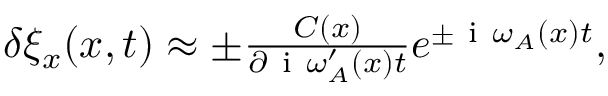Convert formula to latex. <formula><loc_0><loc_0><loc_500><loc_500>\begin{array} { r } { \delta \xi _ { x } ( x , t ) \approx \pm \frac { C ( x ) } { \partial i \omega _ { A } ^ { \prime } ( x ) t } e ^ { \pm i \omega _ { A } ( x ) t } , } \end{array}</formula> 